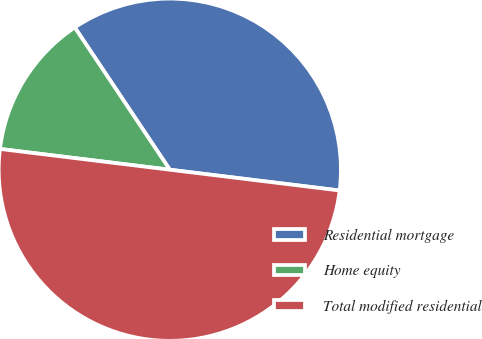Convert chart to OTSL. <chart><loc_0><loc_0><loc_500><loc_500><pie_chart><fcel>Residential mortgage<fcel>Home equity<fcel>Total modified residential<nl><fcel>36.31%<fcel>13.69%<fcel>50.0%<nl></chart> 